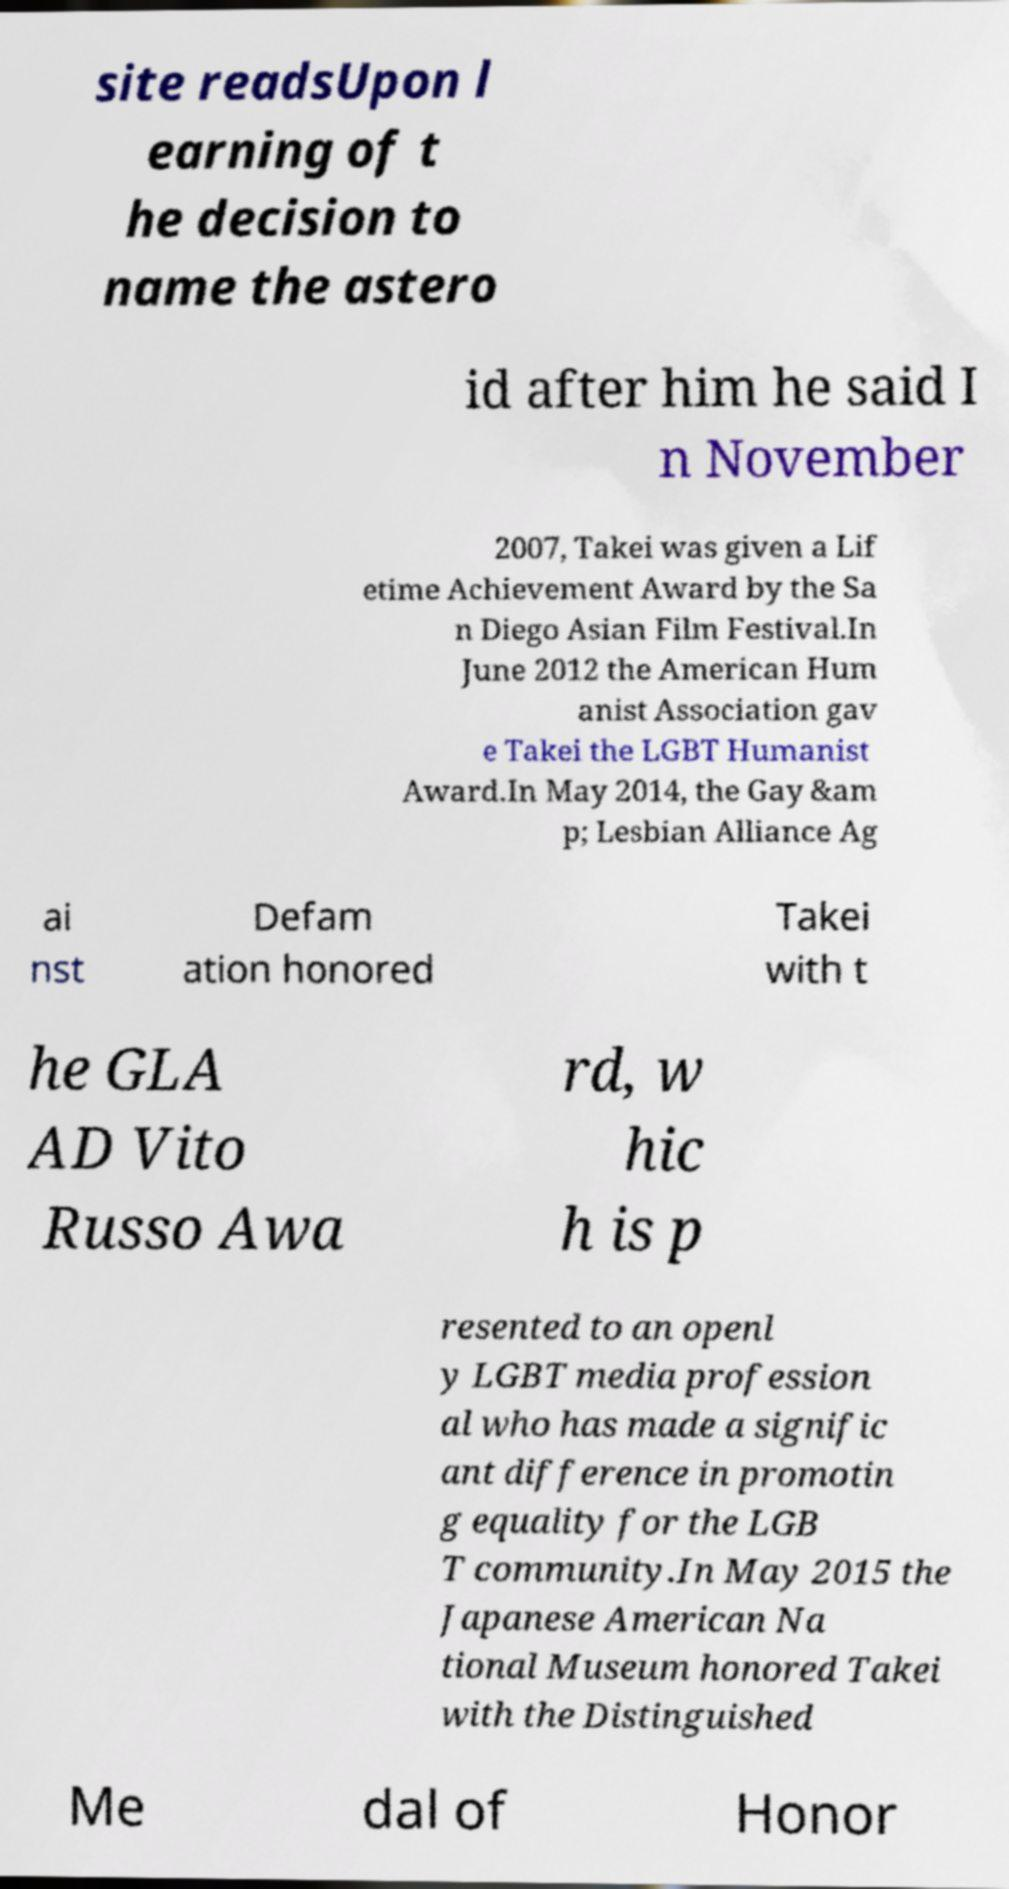Can you accurately transcribe the text from the provided image for me? site readsUpon l earning of t he decision to name the astero id after him he said I n November 2007, Takei was given a Lif etime Achievement Award by the Sa n Diego Asian Film Festival.In June 2012 the American Hum anist Association gav e Takei the LGBT Humanist Award.In May 2014, the Gay &am p; Lesbian Alliance Ag ai nst Defam ation honored Takei with t he GLA AD Vito Russo Awa rd, w hic h is p resented to an openl y LGBT media profession al who has made a signific ant difference in promotin g equality for the LGB T community.In May 2015 the Japanese American Na tional Museum honored Takei with the Distinguished Me dal of Honor 